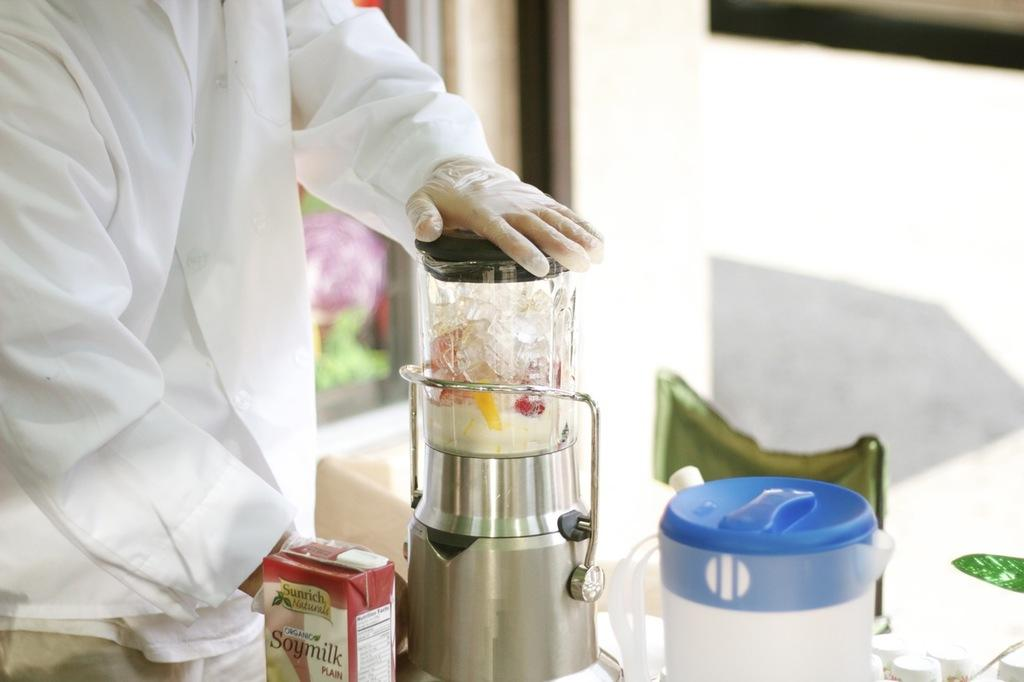<image>
Summarize the visual content of the image. A carton of soymilk sits on a counter near a blender. 